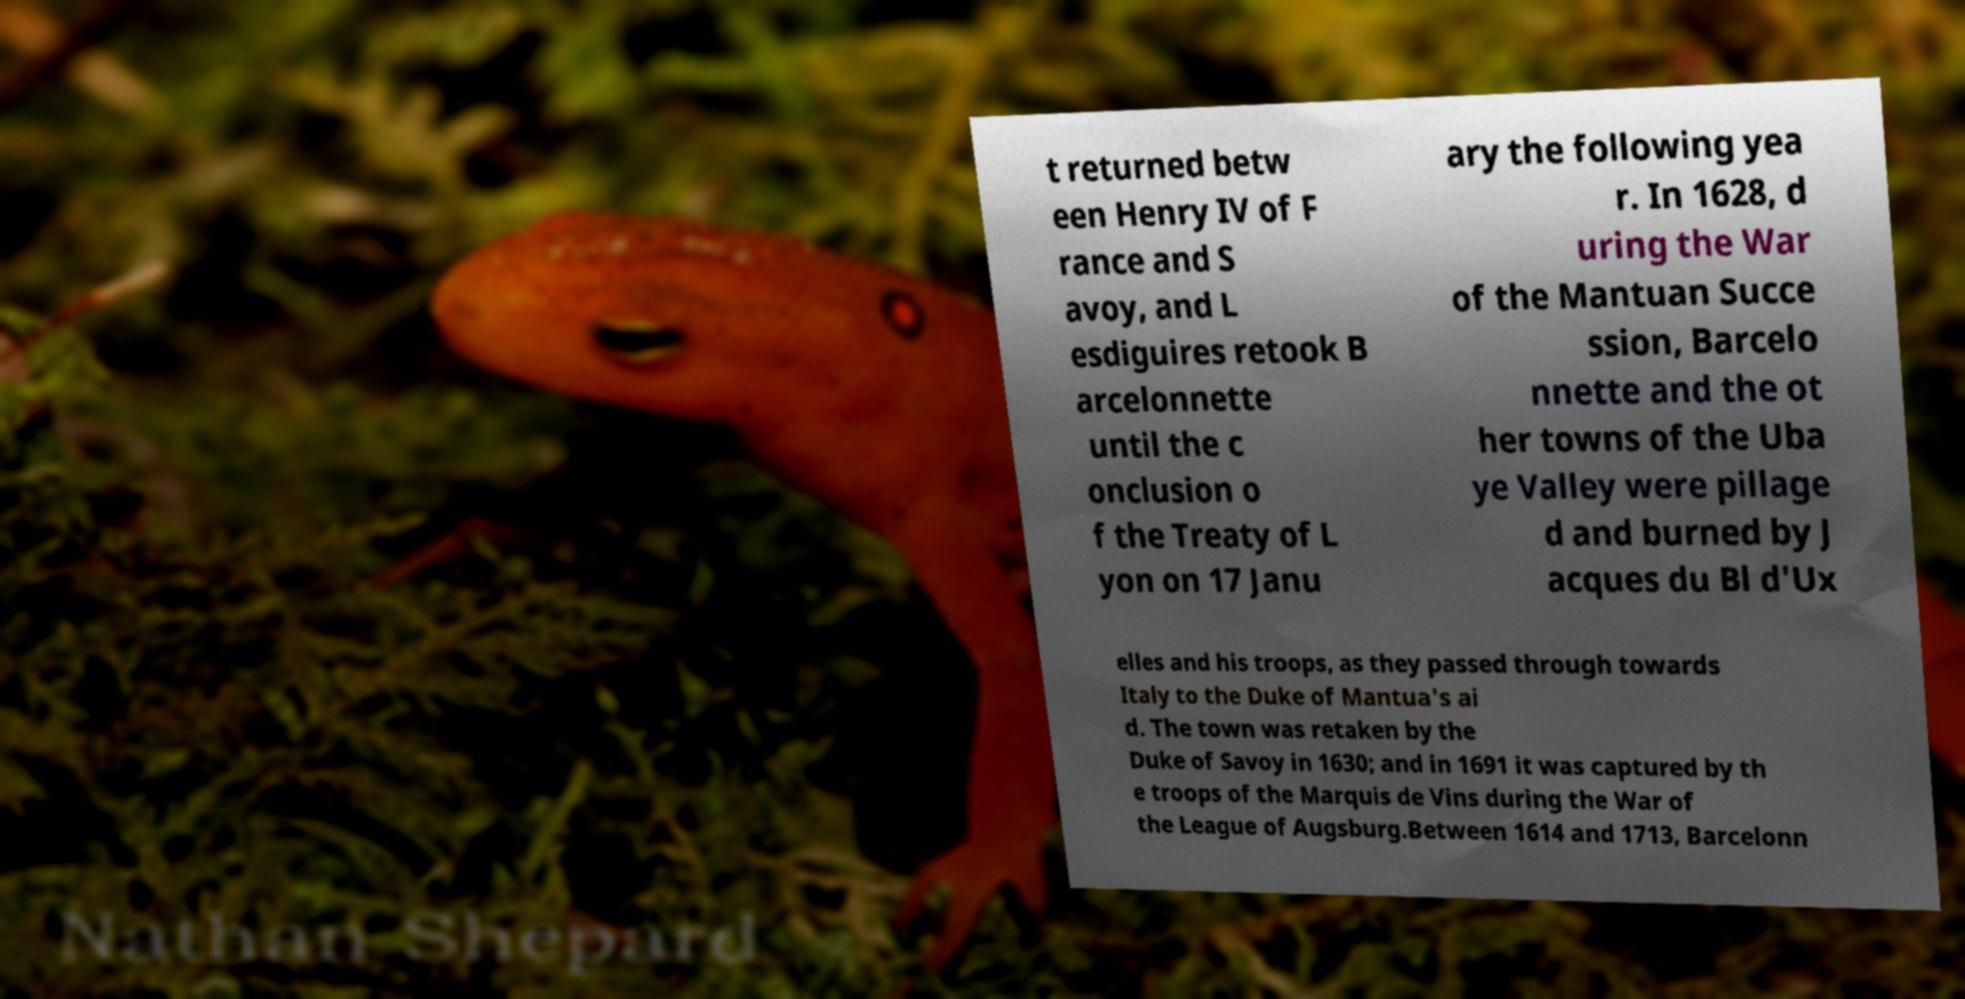Please read and relay the text visible in this image. What does it say? t returned betw een Henry IV of F rance and S avoy, and L esdiguires retook B arcelonnette until the c onclusion o f the Treaty of L yon on 17 Janu ary the following yea r. In 1628, d uring the War of the Mantuan Succe ssion, Barcelo nnette and the ot her towns of the Uba ye Valley were pillage d and burned by J acques du Bl d'Ux elles and his troops, as they passed through towards Italy to the Duke of Mantua's ai d. The town was retaken by the Duke of Savoy in 1630; and in 1691 it was captured by th e troops of the Marquis de Vins during the War of the League of Augsburg.Between 1614 and 1713, Barcelonn 